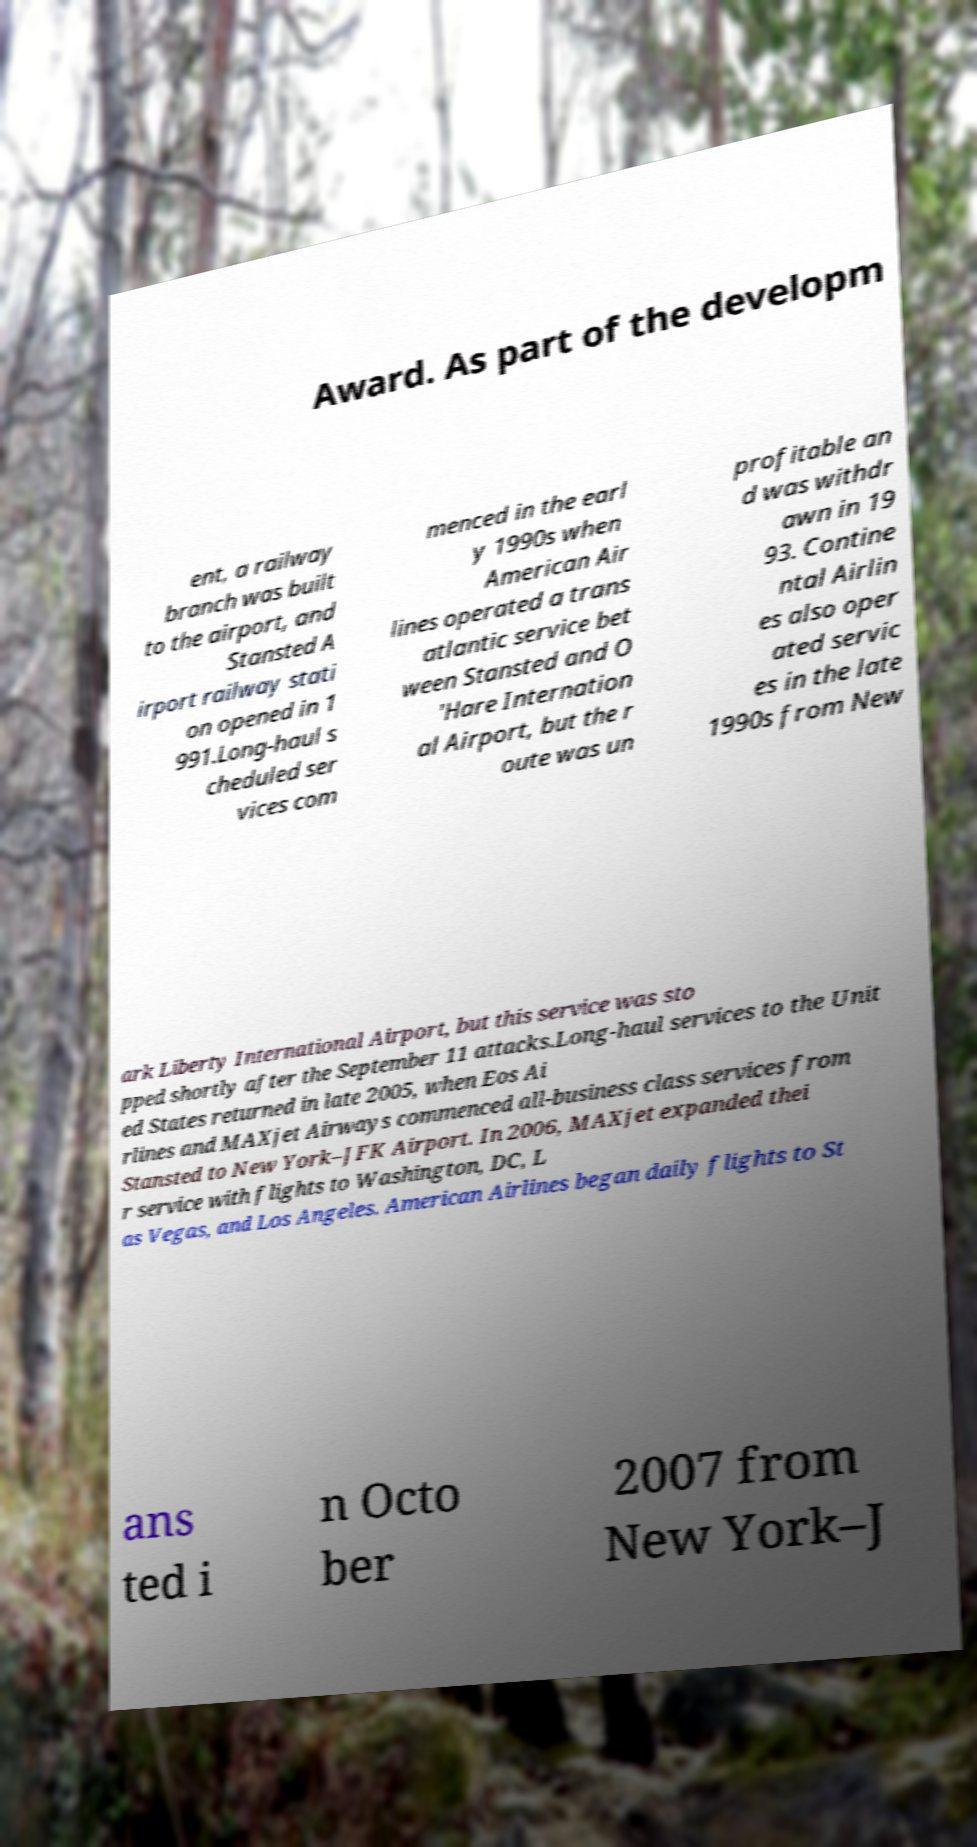Please read and relay the text visible in this image. What does it say? Award. As part of the developm ent, a railway branch was built to the airport, and Stansted A irport railway stati on opened in 1 991.Long-haul s cheduled ser vices com menced in the earl y 1990s when American Air lines operated a trans atlantic service bet ween Stansted and O 'Hare Internation al Airport, but the r oute was un profitable an d was withdr awn in 19 93. Contine ntal Airlin es also oper ated servic es in the late 1990s from New ark Liberty International Airport, but this service was sto pped shortly after the September 11 attacks.Long-haul services to the Unit ed States returned in late 2005, when Eos Ai rlines and MAXjet Airways commenced all-business class services from Stansted to New York–JFK Airport. In 2006, MAXjet expanded thei r service with flights to Washington, DC, L as Vegas, and Los Angeles. American Airlines began daily flights to St ans ted i n Octo ber 2007 from New York–J 